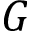Convert formula to latex. <formula><loc_0><loc_0><loc_500><loc_500>G</formula> 